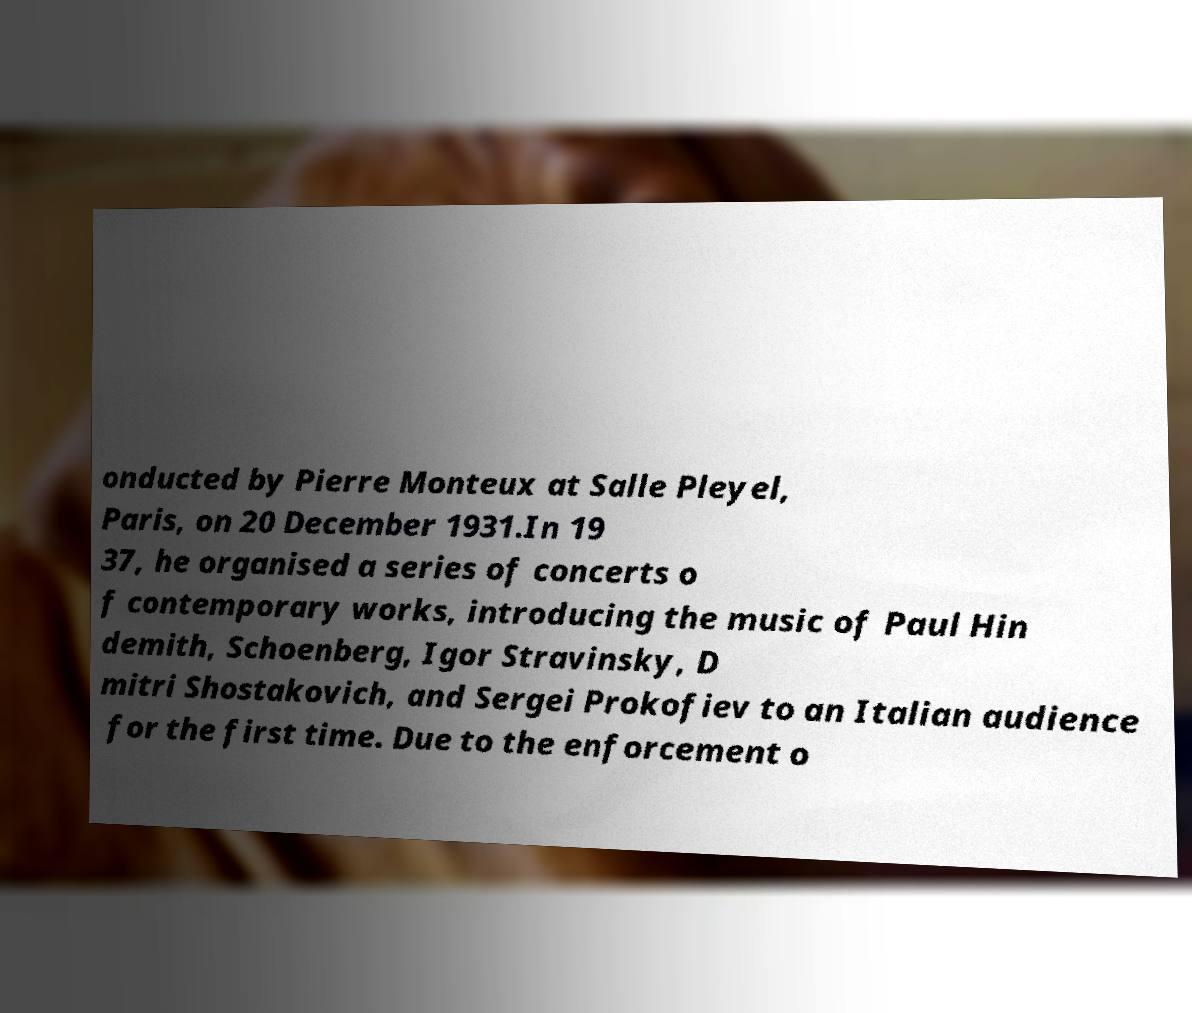Please read and relay the text visible in this image. What does it say? onducted by Pierre Monteux at Salle Pleyel, Paris, on 20 December 1931.In 19 37, he organised a series of concerts o f contemporary works, introducing the music of Paul Hin demith, Schoenberg, Igor Stravinsky, D mitri Shostakovich, and Sergei Prokofiev to an Italian audience for the first time. Due to the enforcement o 